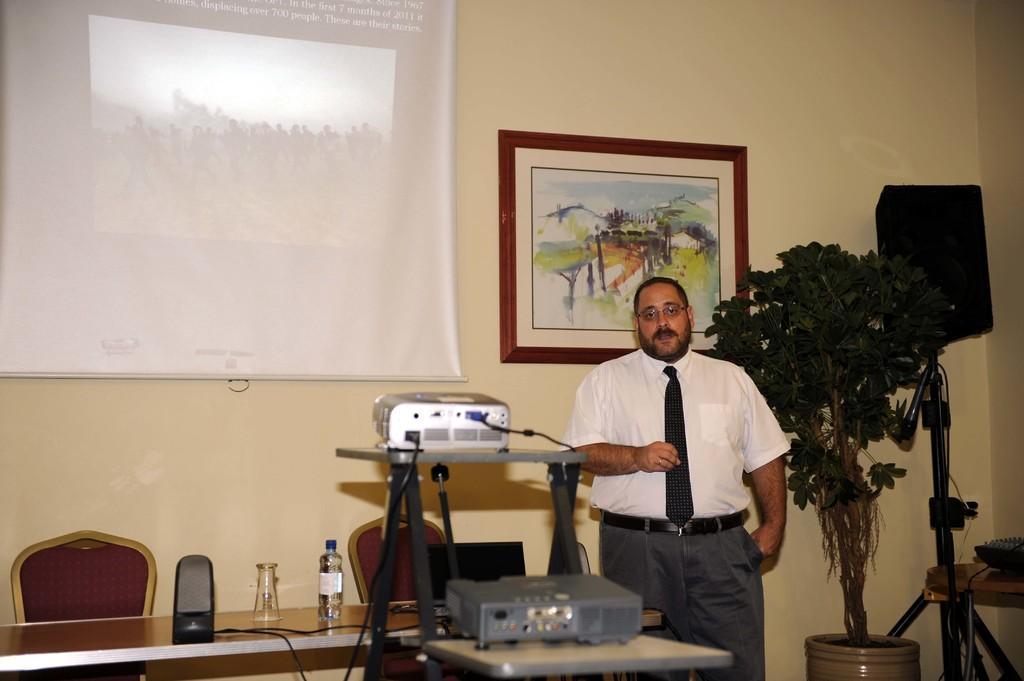How would you summarize this image in a sentence or two? In this image we can see a man is standing, he is wearing white shirt and grey pant. Beside him one plant and one tripod stand is there. Behind him one wall is there, on wall one frame and screen is attached. To the right side of the image one table and chairs are there. On table speaker, glass and bottle is present. In front of the table, one stand is there. On the top of the stand projectors are present. 